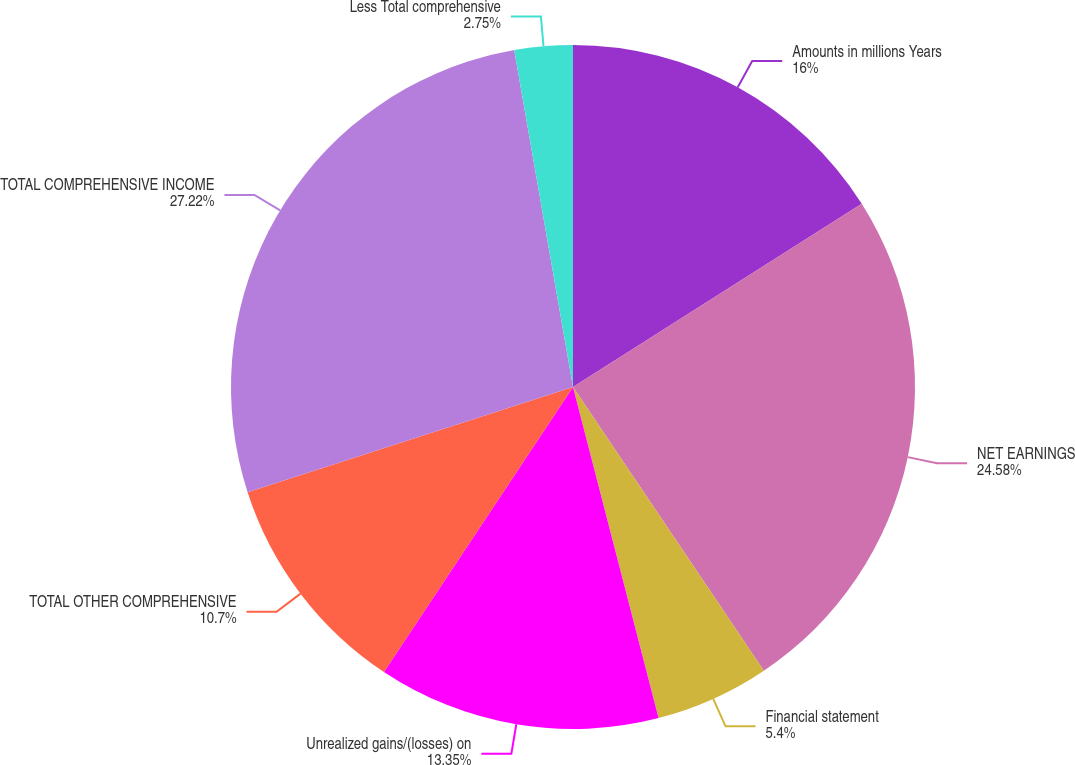Convert chart. <chart><loc_0><loc_0><loc_500><loc_500><pie_chart><fcel>Amounts in millions Years<fcel>NET EARNINGS<fcel>Financial statement<fcel>Unrealized gains/(losses) on<fcel>TOTAL OTHER COMPREHENSIVE<fcel>TOTAL COMPREHENSIVE INCOME<fcel>Less Total comprehensive<nl><fcel>16.0%<fcel>24.58%<fcel>5.4%<fcel>13.35%<fcel>10.7%<fcel>27.23%<fcel>2.75%<nl></chart> 